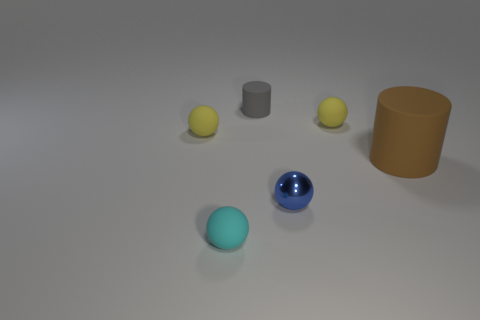Is there any other thing that is the same material as the small blue thing?
Your response must be concise. No. There is a tiny rubber sphere on the right side of the small thing that is in front of the metallic ball; how many blue metal spheres are right of it?
Keep it short and to the point. 0. How many small objects are yellow matte spheres or cyan spheres?
Offer a very short reply. 3. Is the material of the tiny thing right of the small blue metallic thing the same as the large cylinder?
Make the answer very short. Yes. What is the material of the small blue thing to the left of the tiny matte sphere right of the matte cylinder that is behind the big rubber cylinder?
Your answer should be very brief. Metal. Are there any other things that have the same size as the blue metal object?
Your response must be concise. Yes. How many rubber things are tiny blue cylinders or cyan objects?
Your answer should be compact. 1. Are any small gray things visible?
Your response must be concise. Yes. There is a tiny ball left of the thing that is in front of the small metal object; what is its color?
Offer a very short reply. Yellow. What number of other objects are the same color as the shiny object?
Offer a terse response. 0. 